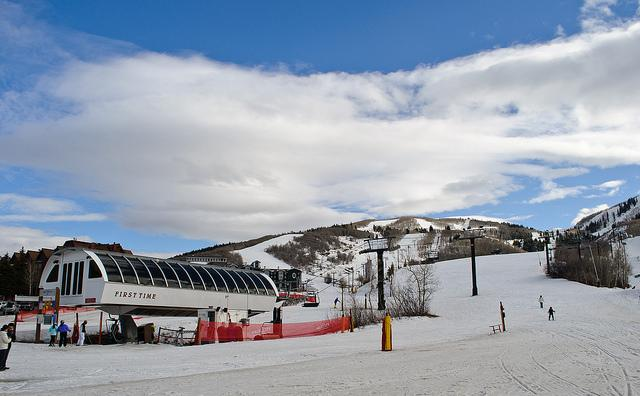Which skiers gather under the pavilion nearest here? Please explain your reasoning. beginners. Young skiers are on a ski hill that is not very steep. 